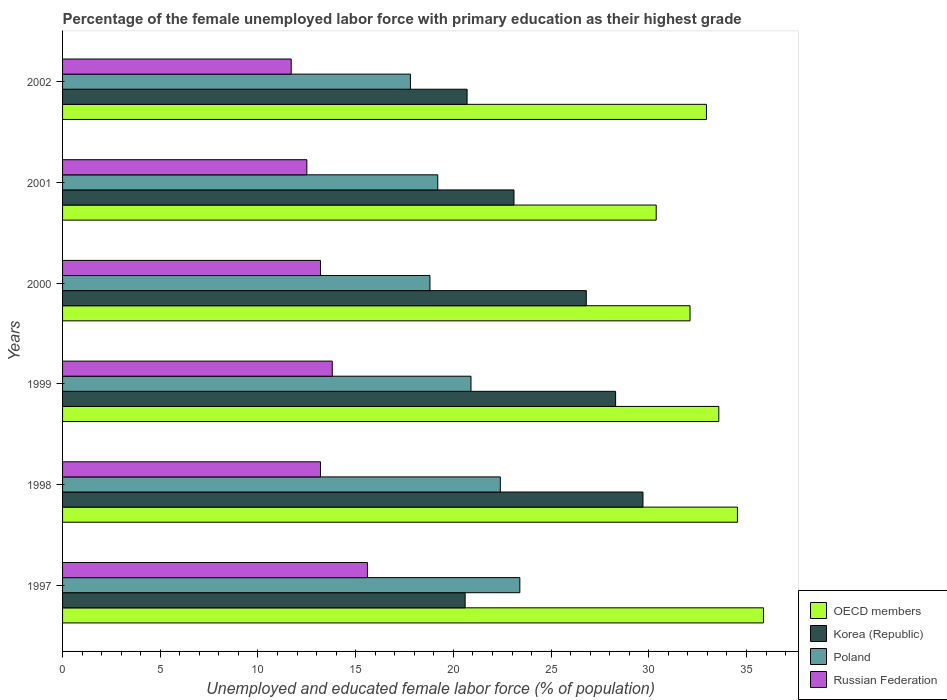How many different coloured bars are there?
Keep it short and to the point. 4. How many groups of bars are there?
Make the answer very short. 6. Are the number of bars per tick equal to the number of legend labels?
Ensure brevity in your answer.  Yes. Are the number of bars on each tick of the Y-axis equal?
Your answer should be very brief. Yes. What is the label of the 2nd group of bars from the top?
Keep it short and to the point. 2001. What is the percentage of the unemployed female labor force with primary education in OECD members in 1998?
Provide a succinct answer. 34.54. Across all years, what is the maximum percentage of the unemployed female labor force with primary education in OECD members?
Make the answer very short. 35.87. Across all years, what is the minimum percentage of the unemployed female labor force with primary education in Korea (Republic)?
Offer a terse response. 20.6. In which year was the percentage of the unemployed female labor force with primary education in OECD members maximum?
Your answer should be compact. 1997. In which year was the percentage of the unemployed female labor force with primary education in Korea (Republic) minimum?
Your answer should be compact. 1997. What is the total percentage of the unemployed female labor force with primary education in Korea (Republic) in the graph?
Keep it short and to the point. 149.2. What is the difference between the percentage of the unemployed female labor force with primary education in Korea (Republic) in 1999 and that in 2002?
Your answer should be compact. 7.6. What is the difference between the percentage of the unemployed female labor force with primary education in Korea (Republic) in 1998 and the percentage of the unemployed female labor force with primary education in OECD members in 2001?
Keep it short and to the point. -0.68. What is the average percentage of the unemployed female labor force with primary education in Russian Federation per year?
Make the answer very short. 13.33. In the year 1997, what is the difference between the percentage of the unemployed female labor force with primary education in Korea (Republic) and percentage of the unemployed female labor force with primary education in Russian Federation?
Provide a succinct answer. 5. In how many years, is the percentage of the unemployed female labor force with primary education in Russian Federation greater than 33 %?
Your answer should be very brief. 0. What is the ratio of the percentage of the unemployed female labor force with primary education in Russian Federation in 1997 to that in 2002?
Your answer should be very brief. 1.33. Is the percentage of the unemployed female labor force with primary education in Russian Federation in 1997 less than that in 2000?
Give a very brief answer. No. What is the difference between the highest and the second highest percentage of the unemployed female labor force with primary education in Russian Federation?
Offer a very short reply. 1.8. What is the difference between the highest and the lowest percentage of the unemployed female labor force with primary education in OECD members?
Provide a succinct answer. 5.49. Is the sum of the percentage of the unemployed female labor force with primary education in OECD members in 1997 and 1998 greater than the maximum percentage of the unemployed female labor force with primary education in Russian Federation across all years?
Offer a very short reply. Yes. Is it the case that in every year, the sum of the percentage of the unemployed female labor force with primary education in Korea (Republic) and percentage of the unemployed female labor force with primary education in Russian Federation is greater than the sum of percentage of the unemployed female labor force with primary education in Poland and percentage of the unemployed female labor force with primary education in OECD members?
Keep it short and to the point. Yes. What does the 2nd bar from the top in 1998 represents?
Ensure brevity in your answer.  Poland. What is the difference between two consecutive major ticks on the X-axis?
Keep it short and to the point. 5. Are the values on the major ticks of X-axis written in scientific E-notation?
Ensure brevity in your answer.  No. Does the graph contain any zero values?
Your answer should be compact. No. Does the graph contain grids?
Ensure brevity in your answer.  No. How many legend labels are there?
Offer a terse response. 4. How are the legend labels stacked?
Give a very brief answer. Vertical. What is the title of the graph?
Make the answer very short. Percentage of the female unemployed labor force with primary education as their highest grade. Does "Haiti" appear as one of the legend labels in the graph?
Your response must be concise. No. What is the label or title of the X-axis?
Provide a short and direct response. Unemployed and educated female labor force (% of population). What is the label or title of the Y-axis?
Give a very brief answer. Years. What is the Unemployed and educated female labor force (% of population) in OECD members in 1997?
Offer a terse response. 35.87. What is the Unemployed and educated female labor force (% of population) of Korea (Republic) in 1997?
Offer a terse response. 20.6. What is the Unemployed and educated female labor force (% of population) in Poland in 1997?
Offer a terse response. 23.4. What is the Unemployed and educated female labor force (% of population) in Russian Federation in 1997?
Give a very brief answer. 15.6. What is the Unemployed and educated female labor force (% of population) of OECD members in 1998?
Your answer should be compact. 34.54. What is the Unemployed and educated female labor force (% of population) of Korea (Republic) in 1998?
Offer a very short reply. 29.7. What is the Unemployed and educated female labor force (% of population) in Poland in 1998?
Provide a short and direct response. 22.4. What is the Unemployed and educated female labor force (% of population) of Russian Federation in 1998?
Your answer should be very brief. 13.2. What is the Unemployed and educated female labor force (% of population) of OECD members in 1999?
Offer a terse response. 33.58. What is the Unemployed and educated female labor force (% of population) of Korea (Republic) in 1999?
Give a very brief answer. 28.3. What is the Unemployed and educated female labor force (% of population) of Poland in 1999?
Offer a terse response. 20.9. What is the Unemployed and educated female labor force (% of population) in Russian Federation in 1999?
Provide a short and direct response. 13.8. What is the Unemployed and educated female labor force (% of population) in OECD members in 2000?
Make the answer very short. 32.11. What is the Unemployed and educated female labor force (% of population) in Korea (Republic) in 2000?
Offer a very short reply. 26.8. What is the Unemployed and educated female labor force (% of population) of Poland in 2000?
Ensure brevity in your answer.  18.8. What is the Unemployed and educated female labor force (% of population) of Russian Federation in 2000?
Provide a short and direct response. 13.2. What is the Unemployed and educated female labor force (% of population) in OECD members in 2001?
Keep it short and to the point. 30.38. What is the Unemployed and educated female labor force (% of population) in Korea (Republic) in 2001?
Ensure brevity in your answer.  23.1. What is the Unemployed and educated female labor force (% of population) in Poland in 2001?
Keep it short and to the point. 19.2. What is the Unemployed and educated female labor force (% of population) in OECD members in 2002?
Your answer should be compact. 32.95. What is the Unemployed and educated female labor force (% of population) in Korea (Republic) in 2002?
Give a very brief answer. 20.7. What is the Unemployed and educated female labor force (% of population) in Poland in 2002?
Your response must be concise. 17.8. What is the Unemployed and educated female labor force (% of population) in Russian Federation in 2002?
Your answer should be very brief. 11.7. Across all years, what is the maximum Unemployed and educated female labor force (% of population) in OECD members?
Keep it short and to the point. 35.87. Across all years, what is the maximum Unemployed and educated female labor force (% of population) of Korea (Republic)?
Offer a very short reply. 29.7. Across all years, what is the maximum Unemployed and educated female labor force (% of population) in Poland?
Your answer should be very brief. 23.4. Across all years, what is the maximum Unemployed and educated female labor force (% of population) of Russian Federation?
Your response must be concise. 15.6. Across all years, what is the minimum Unemployed and educated female labor force (% of population) in OECD members?
Offer a terse response. 30.38. Across all years, what is the minimum Unemployed and educated female labor force (% of population) of Korea (Republic)?
Provide a short and direct response. 20.6. Across all years, what is the minimum Unemployed and educated female labor force (% of population) of Poland?
Your response must be concise. 17.8. Across all years, what is the minimum Unemployed and educated female labor force (% of population) of Russian Federation?
Keep it short and to the point. 11.7. What is the total Unemployed and educated female labor force (% of population) in OECD members in the graph?
Keep it short and to the point. 199.42. What is the total Unemployed and educated female labor force (% of population) in Korea (Republic) in the graph?
Make the answer very short. 149.2. What is the total Unemployed and educated female labor force (% of population) in Poland in the graph?
Your response must be concise. 122.5. What is the total Unemployed and educated female labor force (% of population) of Russian Federation in the graph?
Keep it short and to the point. 80. What is the difference between the Unemployed and educated female labor force (% of population) of OECD members in 1997 and that in 1998?
Make the answer very short. 1.33. What is the difference between the Unemployed and educated female labor force (% of population) in Poland in 1997 and that in 1998?
Provide a succinct answer. 1. What is the difference between the Unemployed and educated female labor force (% of population) of Russian Federation in 1997 and that in 1998?
Ensure brevity in your answer.  2.4. What is the difference between the Unemployed and educated female labor force (% of population) in OECD members in 1997 and that in 1999?
Your response must be concise. 2.29. What is the difference between the Unemployed and educated female labor force (% of population) of Russian Federation in 1997 and that in 1999?
Keep it short and to the point. 1.8. What is the difference between the Unemployed and educated female labor force (% of population) in OECD members in 1997 and that in 2000?
Offer a very short reply. 3.76. What is the difference between the Unemployed and educated female labor force (% of population) in Korea (Republic) in 1997 and that in 2000?
Your answer should be compact. -6.2. What is the difference between the Unemployed and educated female labor force (% of population) of Poland in 1997 and that in 2000?
Your answer should be very brief. 4.6. What is the difference between the Unemployed and educated female labor force (% of population) of OECD members in 1997 and that in 2001?
Offer a very short reply. 5.49. What is the difference between the Unemployed and educated female labor force (% of population) of Russian Federation in 1997 and that in 2001?
Your answer should be compact. 3.1. What is the difference between the Unemployed and educated female labor force (% of population) in OECD members in 1997 and that in 2002?
Offer a very short reply. 2.92. What is the difference between the Unemployed and educated female labor force (% of population) in Poland in 1997 and that in 2002?
Provide a succinct answer. 5.6. What is the difference between the Unemployed and educated female labor force (% of population) of Russian Federation in 1997 and that in 2002?
Your response must be concise. 3.9. What is the difference between the Unemployed and educated female labor force (% of population) in OECD members in 1998 and that in 1999?
Provide a short and direct response. 0.95. What is the difference between the Unemployed and educated female labor force (% of population) in OECD members in 1998 and that in 2000?
Offer a terse response. 2.43. What is the difference between the Unemployed and educated female labor force (% of population) of Poland in 1998 and that in 2000?
Give a very brief answer. 3.6. What is the difference between the Unemployed and educated female labor force (% of population) of OECD members in 1998 and that in 2001?
Your response must be concise. 4.16. What is the difference between the Unemployed and educated female labor force (% of population) in Korea (Republic) in 1998 and that in 2001?
Offer a very short reply. 6.6. What is the difference between the Unemployed and educated female labor force (% of population) in Russian Federation in 1998 and that in 2001?
Offer a very short reply. 0.7. What is the difference between the Unemployed and educated female labor force (% of population) in OECD members in 1998 and that in 2002?
Your response must be concise. 1.59. What is the difference between the Unemployed and educated female labor force (% of population) in Poland in 1998 and that in 2002?
Provide a succinct answer. 4.6. What is the difference between the Unemployed and educated female labor force (% of population) in Russian Federation in 1998 and that in 2002?
Offer a terse response. 1.5. What is the difference between the Unemployed and educated female labor force (% of population) of OECD members in 1999 and that in 2000?
Provide a succinct answer. 1.47. What is the difference between the Unemployed and educated female labor force (% of population) in Korea (Republic) in 1999 and that in 2000?
Provide a succinct answer. 1.5. What is the difference between the Unemployed and educated female labor force (% of population) in OECD members in 1999 and that in 2001?
Ensure brevity in your answer.  3.2. What is the difference between the Unemployed and educated female labor force (% of population) of Poland in 1999 and that in 2001?
Your response must be concise. 1.7. What is the difference between the Unemployed and educated female labor force (% of population) of OECD members in 1999 and that in 2002?
Ensure brevity in your answer.  0.63. What is the difference between the Unemployed and educated female labor force (% of population) in Korea (Republic) in 1999 and that in 2002?
Offer a very short reply. 7.6. What is the difference between the Unemployed and educated female labor force (% of population) of Poland in 1999 and that in 2002?
Make the answer very short. 3.1. What is the difference between the Unemployed and educated female labor force (% of population) in Russian Federation in 1999 and that in 2002?
Make the answer very short. 2.1. What is the difference between the Unemployed and educated female labor force (% of population) of OECD members in 2000 and that in 2001?
Provide a succinct answer. 1.73. What is the difference between the Unemployed and educated female labor force (% of population) in Russian Federation in 2000 and that in 2001?
Keep it short and to the point. 0.7. What is the difference between the Unemployed and educated female labor force (% of population) of OECD members in 2000 and that in 2002?
Offer a terse response. -0.84. What is the difference between the Unemployed and educated female labor force (% of population) in Korea (Republic) in 2000 and that in 2002?
Offer a very short reply. 6.1. What is the difference between the Unemployed and educated female labor force (% of population) of Poland in 2000 and that in 2002?
Provide a succinct answer. 1. What is the difference between the Unemployed and educated female labor force (% of population) of Russian Federation in 2000 and that in 2002?
Your answer should be very brief. 1.5. What is the difference between the Unemployed and educated female labor force (% of population) of OECD members in 2001 and that in 2002?
Make the answer very short. -2.57. What is the difference between the Unemployed and educated female labor force (% of population) of Poland in 2001 and that in 2002?
Ensure brevity in your answer.  1.4. What is the difference between the Unemployed and educated female labor force (% of population) in OECD members in 1997 and the Unemployed and educated female labor force (% of population) in Korea (Republic) in 1998?
Provide a short and direct response. 6.17. What is the difference between the Unemployed and educated female labor force (% of population) of OECD members in 1997 and the Unemployed and educated female labor force (% of population) of Poland in 1998?
Make the answer very short. 13.47. What is the difference between the Unemployed and educated female labor force (% of population) in OECD members in 1997 and the Unemployed and educated female labor force (% of population) in Russian Federation in 1998?
Provide a succinct answer. 22.67. What is the difference between the Unemployed and educated female labor force (% of population) of Korea (Republic) in 1997 and the Unemployed and educated female labor force (% of population) of Poland in 1998?
Make the answer very short. -1.8. What is the difference between the Unemployed and educated female labor force (% of population) of Korea (Republic) in 1997 and the Unemployed and educated female labor force (% of population) of Russian Federation in 1998?
Make the answer very short. 7.4. What is the difference between the Unemployed and educated female labor force (% of population) in Poland in 1997 and the Unemployed and educated female labor force (% of population) in Russian Federation in 1998?
Offer a very short reply. 10.2. What is the difference between the Unemployed and educated female labor force (% of population) of OECD members in 1997 and the Unemployed and educated female labor force (% of population) of Korea (Republic) in 1999?
Provide a short and direct response. 7.57. What is the difference between the Unemployed and educated female labor force (% of population) in OECD members in 1997 and the Unemployed and educated female labor force (% of population) in Poland in 1999?
Your answer should be very brief. 14.97. What is the difference between the Unemployed and educated female labor force (% of population) in OECD members in 1997 and the Unemployed and educated female labor force (% of population) in Russian Federation in 1999?
Your response must be concise. 22.07. What is the difference between the Unemployed and educated female labor force (% of population) of Korea (Republic) in 1997 and the Unemployed and educated female labor force (% of population) of Poland in 1999?
Offer a very short reply. -0.3. What is the difference between the Unemployed and educated female labor force (% of population) of Poland in 1997 and the Unemployed and educated female labor force (% of population) of Russian Federation in 1999?
Offer a very short reply. 9.6. What is the difference between the Unemployed and educated female labor force (% of population) of OECD members in 1997 and the Unemployed and educated female labor force (% of population) of Korea (Republic) in 2000?
Offer a terse response. 9.07. What is the difference between the Unemployed and educated female labor force (% of population) in OECD members in 1997 and the Unemployed and educated female labor force (% of population) in Poland in 2000?
Offer a very short reply. 17.07. What is the difference between the Unemployed and educated female labor force (% of population) of OECD members in 1997 and the Unemployed and educated female labor force (% of population) of Russian Federation in 2000?
Your response must be concise. 22.67. What is the difference between the Unemployed and educated female labor force (% of population) in Korea (Republic) in 1997 and the Unemployed and educated female labor force (% of population) in Poland in 2000?
Make the answer very short. 1.8. What is the difference between the Unemployed and educated female labor force (% of population) in Korea (Republic) in 1997 and the Unemployed and educated female labor force (% of population) in Russian Federation in 2000?
Your response must be concise. 7.4. What is the difference between the Unemployed and educated female labor force (% of population) in OECD members in 1997 and the Unemployed and educated female labor force (% of population) in Korea (Republic) in 2001?
Your answer should be compact. 12.77. What is the difference between the Unemployed and educated female labor force (% of population) of OECD members in 1997 and the Unemployed and educated female labor force (% of population) of Poland in 2001?
Your response must be concise. 16.67. What is the difference between the Unemployed and educated female labor force (% of population) of OECD members in 1997 and the Unemployed and educated female labor force (% of population) of Russian Federation in 2001?
Provide a short and direct response. 23.37. What is the difference between the Unemployed and educated female labor force (% of population) of Korea (Republic) in 1997 and the Unemployed and educated female labor force (% of population) of Poland in 2001?
Give a very brief answer. 1.4. What is the difference between the Unemployed and educated female labor force (% of population) of Poland in 1997 and the Unemployed and educated female labor force (% of population) of Russian Federation in 2001?
Provide a succinct answer. 10.9. What is the difference between the Unemployed and educated female labor force (% of population) of OECD members in 1997 and the Unemployed and educated female labor force (% of population) of Korea (Republic) in 2002?
Make the answer very short. 15.17. What is the difference between the Unemployed and educated female labor force (% of population) in OECD members in 1997 and the Unemployed and educated female labor force (% of population) in Poland in 2002?
Give a very brief answer. 18.07. What is the difference between the Unemployed and educated female labor force (% of population) in OECD members in 1997 and the Unemployed and educated female labor force (% of population) in Russian Federation in 2002?
Offer a very short reply. 24.17. What is the difference between the Unemployed and educated female labor force (% of population) in Korea (Republic) in 1997 and the Unemployed and educated female labor force (% of population) in Poland in 2002?
Give a very brief answer. 2.8. What is the difference between the Unemployed and educated female labor force (% of population) in OECD members in 1998 and the Unemployed and educated female labor force (% of population) in Korea (Republic) in 1999?
Offer a very short reply. 6.24. What is the difference between the Unemployed and educated female labor force (% of population) of OECD members in 1998 and the Unemployed and educated female labor force (% of population) of Poland in 1999?
Your answer should be very brief. 13.64. What is the difference between the Unemployed and educated female labor force (% of population) in OECD members in 1998 and the Unemployed and educated female labor force (% of population) in Russian Federation in 1999?
Offer a very short reply. 20.74. What is the difference between the Unemployed and educated female labor force (% of population) of Korea (Republic) in 1998 and the Unemployed and educated female labor force (% of population) of Poland in 1999?
Your answer should be very brief. 8.8. What is the difference between the Unemployed and educated female labor force (% of population) in Korea (Republic) in 1998 and the Unemployed and educated female labor force (% of population) in Russian Federation in 1999?
Your answer should be compact. 15.9. What is the difference between the Unemployed and educated female labor force (% of population) of OECD members in 1998 and the Unemployed and educated female labor force (% of population) of Korea (Republic) in 2000?
Give a very brief answer. 7.74. What is the difference between the Unemployed and educated female labor force (% of population) in OECD members in 1998 and the Unemployed and educated female labor force (% of population) in Poland in 2000?
Offer a very short reply. 15.74. What is the difference between the Unemployed and educated female labor force (% of population) of OECD members in 1998 and the Unemployed and educated female labor force (% of population) of Russian Federation in 2000?
Keep it short and to the point. 21.34. What is the difference between the Unemployed and educated female labor force (% of population) of Korea (Republic) in 1998 and the Unemployed and educated female labor force (% of population) of Poland in 2000?
Provide a succinct answer. 10.9. What is the difference between the Unemployed and educated female labor force (% of population) in Korea (Republic) in 1998 and the Unemployed and educated female labor force (% of population) in Russian Federation in 2000?
Ensure brevity in your answer.  16.5. What is the difference between the Unemployed and educated female labor force (% of population) in Poland in 1998 and the Unemployed and educated female labor force (% of population) in Russian Federation in 2000?
Your answer should be very brief. 9.2. What is the difference between the Unemployed and educated female labor force (% of population) of OECD members in 1998 and the Unemployed and educated female labor force (% of population) of Korea (Republic) in 2001?
Offer a terse response. 11.44. What is the difference between the Unemployed and educated female labor force (% of population) of OECD members in 1998 and the Unemployed and educated female labor force (% of population) of Poland in 2001?
Your response must be concise. 15.34. What is the difference between the Unemployed and educated female labor force (% of population) in OECD members in 1998 and the Unemployed and educated female labor force (% of population) in Russian Federation in 2001?
Ensure brevity in your answer.  22.04. What is the difference between the Unemployed and educated female labor force (% of population) in Korea (Republic) in 1998 and the Unemployed and educated female labor force (% of population) in Poland in 2001?
Offer a very short reply. 10.5. What is the difference between the Unemployed and educated female labor force (% of population) in OECD members in 1998 and the Unemployed and educated female labor force (% of population) in Korea (Republic) in 2002?
Your answer should be compact. 13.84. What is the difference between the Unemployed and educated female labor force (% of population) in OECD members in 1998 and the Unemployed and educated female labor force (% of population) in Poland in 2002?
Provide a short and direct response. 16.74. What is the difference between the Unemployed and educated female labor force (% of population) of OECD members in 1998 and the Unemployed and educated female labor force (% of population) of Russian Federation in 2002?
Ensure brevity in your answer.  22.84. What is the difference between the Unemployed and educated female labor force (% of population) in Korea (Republic) in 1998 and the Unemployed and educated female labor force (% of population) in Poland in 2002?
Your answer should be compact. 11.9. What is the difference between the Unemployed and educated female labor force (% of population) in Poland in 1998 and the Unemployed and educated female labor force (% of population) in Russian Federation in 2002?
Keep it short and to the point. 10.7. What is the difference between the Unemployed and educated female labor force (% of population) in OECD members in 1999 and the Unemployed and educated female labor force (% of population) in Korea (Republic) in 2000?
Offer a very short reply. 6.78. What is the difference between the Unemployed and educated female labor force (% of population) of OECD members in 1999 and the Unemployed and educated female labor force (% of population) of Poland in 2000?
Offer a terse response. 14.78. What is the difference between the Unemployed and educated female labor force (% of population) in OECD members in 1999 and the Unemployed and educated female labor force (% of population) in Russian Federation in 2000?
Provide a succinct answer. 20.38. What is the difference between the Unemployed and educated female labor force (% of population) in Korea (Republic) in 1999 and the Unemployed and educated female labor force (% of population) in Russian Federation in 2000?
Ensure brevity in your answer.  15.1. What is the difference between the Unemployed and educated female labor force (% of population) of Poland in 1999 and the Unemployed and educated female labor force (% of population) of Russian Federation in 2000?
Your answer should be very brief. 7.7. What is the difference between the Unemployed and educated female labor force (% of population) in OECD members in 1999 and the Unemployed and educated female labor force (% of population) in Korea (Republic) in 2001?
Your answer should be compact. 10.48. What is the difference between the Unemployed and educated female labor force (% of population) of OECD members in 1999 and the Unemployed and educated female labor force (% of population) of Poland in 2001?
Keep it short and to the point. 14.38. What is the difference between the Unemployed and educated female labor force (% of population) in OECD members in 1999 and the Unemployed and educated female labor force (% of population) in Russian Federation in 2001?
Offer a terse response. 21.08. What is the difference between the Unemployed and educated female labor force (% of population) in Korea (Republic) in 1999 and the Unemployed and educated female labor force (% of population) in Russian Federation in 2001?
Make the answer very short. 15.8. What is the difference between the Unemployed and educated female labor force (% of population) of Poland in 1999 and the Unemployed and educated female labor force (% of population) of Russian Federation in 2001?
Ensure brevity in your answer.  8.4. What is the difference between the Unemployed and educated female labor force (% of population) of OECD members in 1999 and the Unemployed and educated female labor force (% of population) of Korea (Republic) in 2002?
Offer a terse response. 12.88. What is the difference between the Unemployed and educated female labor force (% of population) of OECD members in 1999 and the Unemployed and educated female labor force (% of population) of Poland in 2002?
Offer a terse response. 15.78. What is the difference between the Unemployed and educated female labor force (% of population) of OECD members in 1999 and the Unemployed and educated female labor force (% of population) of Russian Federation in 2002?
Provide a succinct answer. 21.88. What is the difference between the Unemployed and educated female labor force (% of population) in Korea (Republic) in 1999 and the Unemployed and educated female labor force (% of population) in Poland in 2002?
Provide a succinct answer. 10.5. What is the difference between the Unemployed and educated female labor force (% of population) in Korea (Republic) in 1999 and the Unemployed and educated female labor force (% of population) in Russian Federation in 2002?
Your answer should be very brief. 16.6. What is the difference between the Unemployed and educated female labor force (% of population) in OECD members in 2000 and the Unemployed and educated female labor force (% of population) in Korea (Republic) in 2001?
Offer a terse response. 9.01. What is the difference between the Unemployed and educated female labor force (% of population) of OECD members in 2000 and the Unemployed and educated female labor force (% of population) of Poland in 2001?
Give a very brief answer. 12.91. What is the difference between the Unemployed and educated female labor force (% of population) of OECD members in 2000 and the Unemployed and educated female labor force (% of population) of Russian Federation in 2001?
Ensure brevity in your answer.  19.61. What is the difference between the Unemployed and educated female labor force (% of population) of Korea (Republic) in 2000 and the Unemployed and educated female labor force (% of population) of Poland in 2001?
Your response must be concise. 7.6. What is the difference between the Unemployed and educated female labor force (% of population) in OECD members in 2000 and the Unemployed and educated female labor force (% of population) in Korea (Republic) in 2002?
Your response must be concise. 11.41. What is the difference between the Unemployed and educated female labor force (% of population) of OECD members in 2000 and the Unemployed and educated female labor force (% of population) of Poland in 2002?
Your answer should be very brief. 14.31. What is the difference between the Unemployed and educated female labor force (% of population) of OECD members in 2000 and the Unemployed and educated female labor force (% of population) of Russian Federation in 2002?
Provide a succinct answer. 20.41. What is the difference between the Unemployed and educated female labor force (% of population) of Korea (Republic) in 2000 and the Unemployed and educated female labor force (% of population) of Russian Federation in 2002?
Your answer should be compact. 15.1. What is the difference between the Unemployed and educated female labor force (% of population) in OECD members in 2001 and the Unemployed and educated female labor force (% of population) in Korea (Republic) in 2002?
Keep it short and to the point. 9.68. What is the difference between the Unemployed and educated female labor force (% of population) in OECD members in 2001 and the Unemployed and educated female labor force (% of population) in Poland in 2002?
Provide a short and direct response. 12.58. What is the difference between the Unemployed and educated female labor force (% of population) in OECD members in 2001 and the Unemployed and educated female labor force (% of population) in Russian Federation in 2002?
Give a very brief answer. 18.68. What is the difference between the Unemployed and educated female labor force (% of population) of Korea (Republic) in 2001 and the Unemployed and educated female labor force (% of population) of Poland in 2002?
Give a very brief answer. 5.3. What is the difference between the Unemployed and educated female labor force (% of population) in Korea (Republic) in 2001 and the Unemployed and educated female labor force (% of population) in Russian Federation in 2002?
Make the answer very short. 11.4. What is the difference between the Unemployed and educated female labor force (% of population) in Poland in 2001 and the Unemployed and educated female labor force (% of population) in Russian Federation in 2002?
Offer a terse response. 7.5. What is the average Unemployed and educated female labor force (% of population) of OECD members per year?
Offer a terse response. 33.24. What is the average Unemployed and educated female labor force (% of population) in Korea (Republic) per year?
Keep it short and to the point. 24.87. What is the average Unemployed and educated female labor force (% of population) of Poland per year?
Your answer should be very brief. 20.42. What is the average Unemployed and educated female labor force (% of population) of Russian Federation per year?
Your answer should be compact. 13.33. In the year 1997, what is the difference between the Unemployed and educated female labor force (% of population) in OECD members and Unemployed and educated female labor force (% of population) in Korea (Republic)?
Your answer should be very brief. 15.27. In the year 1997, what is the difference between the Unemployed and educated female labor force (% of population) of OECD members and Unemployed and educated female labor force (% of population) of Poland?
Your answer should be compact. 12.47. In the year 1997, what is the difference between the Unemployed and educated female labor force (% of population) of OECD members and Unemployed and educated female labor force (% of population) of Russian Federation?
Give a very brief answer. 20.27. In the year 1997, what is the difference between the Unemployed and educated female labor force (% of population) in Korea (Republic) and Unemployed and educated female labor force (% of population) in Poland?
Give a very brief answer. -2.8. In the year 1997, what is the difference between the Unemployed and educated female labor force (% of population) in Korea (Republic) and Unemployed and educated female labor force (% of population) in Russian Federation?
Provide a succinct answer. 5. In the year 1997, what is the difference between the Unemployed and educated female labor force (% of population) in Poland and Unemployed and educated female labor force (% of population) in Russian Federation?
Give a very brief answer. 7.8. In the year 1998, what is the difference between the Unemployed and educated female labor force (% of population) in OECD members and Unemployed and educated female labor force (% of population) in Korea (Republic)?
Offer a terse response. 4.84. In the year 1998, what is the difference between the Unemployed and educated female labor force (% of population) in OECD members and Unemployed and educated female labor force (% of population) in Poland?
Offer a very short reply. 12.14. In the year 1998, what is the difference between the Unemployed and educated female labor force (% of population) in OECD members and Unemployed and educated female labor force (% of population) in Russian Federation?
Provide a succinct answer. 21.34. In the year 1998, what is the difference between the Unemployed and educated female labor force (% of population) of Korea (Republic) and Unemployed and educated female labor force (% of population) of Poland?
Ensure brevity in your answer.  7.3. In the year 1998, what is the difference between the Unemployed and educated female labor force (% of population) of Korea (Republic) and Unemployed and educated female labor force (% of population) of Russian Federation?
Offer a very short reply. 16.5. In the year 1998, what is the difference between the Unemployed and educated female labor force (% of population) in Poland and Unemployed and educated female labor force (% of population) in Russian Federation?
Offer a very short reply. 9.2. In the year 1999, what is the difference between the Unemployed and educated female labor force (% of population) in OECD members and Unemployed and educated female labor force (% of population) in Korea (Republic)?
Offer a very short reply. 5.28. In the year 1999, what is the difference between the Unemployed and educated female labor force (% of population) in OECD members and Unemployed and educated female labor force (% of population) in Poland?
Offer a very short reply. 12.68. In the year 1999, what is the difference between the Unemployed and educated female labor force (% of population) in OECD members and Unemployed and educated female labor force (% of population) in Russian Federation?
Make the answer very short. 19.78. In the year 1999, what is the difference between the Unemployed and educated female labor force (% of population) in Korea (Republic) and Unemployed and educated female labor force (% of population) in Poland?
Your answer should be compact. 7.4. In the year 2000, what is the difference between the Unemployed and educated female labor force (% of population) of OECD members and Unemployed and educated female labor force (% of population) of Korea (Republic)?
Provide a succinct answer. 5.31. In the year 2000, what is the difference between the Unemployed and educated female labor force (% of population) of OECD members and Unemployed and educated female labor force (% of population) of Poland?
Your answer should be very brief. 13.31. In the year 2000, what is the difference between the Unemployed and educated female labor force (% of population) in OECD members and Unemployed and educated female labor force (% of population) in Russian Federation?
Make the answer very short. 18.91. In the year 2001, what is the difference between the Unemployed and educated female labor force (% of population) in OECD members and Unemployed and educated female labor force (% of population) in Korea (Republic)?
Ensure brevity in your answer.  7.28. In the year 2001, what is the difference between the Unemployed and educated female labor force (% of population) in OECD members and Unemployed and educated female labor force (% of population) in Poland?
Offer a terse response. 11.18. In the year 2001, what is the difference between the Unemployed and educated female labor force (% of population) of OECD members and Unemployed and educated female labor force (% of population) of Russian Federation?
Your response must be concise. 17.88. In the year 2001, what is the difference between the Unemployed and educated female labor force (% of population) in Korea (Republic) and Unemployed and educated female labor force (% of population) in Russian Federation?
Your response must be concise. 10.6. In the year 2001, what is the difference between the Unemployed and educated female labor force (% of population) in Poland and Unemployed and educated female labor force (% of population) in Russian Federation?
Offer a terse response. 6.7. In the year 2002, what is the difference between the Unemployed and educated female labor force (% of population) of OECD members and Unemployed and educated female labor force (% of population) of Korea (Republic)?
Keep it short and to the point. 12.25. In the year 2002, what is the difference between the Unemployed and educated female labor force (% of population) of OECD members and Unemployed and educated female labor force (% of population) of Poland?
Make the answer very short. 15.15. In the year 2002, what is the difference between the Unemployed and educated female labor force (% of population) of OECD members and Unemployed and educated female labor force (% of population) of Russian Federation?
Keep it short and to the point. 21.25. In the year 2002, what is the difference between the Unemployed and educated female labor force (% of population) of Korea (Republic) and Unemployed and educated female labor force (% of population) of Poland?
Provide a short and direct response. 2.9. In the year 2002, what is the difference between the Unemployed and educated female labor force (% of population) of Korea (Republic) and Unemployed and educated female labor force (% of population) of Russian Federation?
Your response must be concise. 9. What is the ratio of the Unemployed and educated female labor force (% of population) of OECD members in 1997 to that in 1998?
Ensure brevity in your answer.  1.04. What is the ratio of the Unemployed and educated female labor force (% of population) of Korea (Republic) in 1997 to that in 1998?
Your response must be concise. 0.69. What is the ratio of the Unemployed and educated female labor force (% of population) in Poland in 1997 to that in 1998?
Your answer should be very brief. 1.04. What is the ratio of the Unemployed and educated female labor force (% of population) of Russian Federation in 1997 to that in 1998?
Make the answer very short. 1.18. What is the ratio of the Unemployed and educated female labor force (% of population) of OECD members in 1997 to that in 1999?
Provide a short and direct response. 1.07. What is the ratio of the Unemployed and educated female labor force (% of population) of Korea (Republic) in 1997 to that in 1999?
Ensure brevity in your answer.  0.73. What is the ratio of the Unemployed and educated female labor force (% of population) in Poland in 1997 to that in 1999?
Your answer should be very brief. 1.12. What is the ratio of the Unemployed and educated female labor force (% of population) in Russian Federation in 1997 to that in 1999?
Keep it short and to the point. 1.13. What is the ratio of the Unemployed and educated female labor force (% of population) of OECD members in 1997 to that in 2000?
Provide a short and direct response. 1.12. What is the ratio of the Unemployed and educated female labor force (% of population) of Korea (Republic) in 1997 to that in 2000?
Give a very brief answer. 0.77. What is the ratio of the Unemployed and educated female labor force (% of population) in Poland in 1997 to that in 2000?
Ensure brevity in your answer.  1.24. What is the ratio of the Unemployed and educated female labor force (% of population) in Russian Federation in 1997 to that in 2000?
Keep it short and to the point. 1.18. What is the ratio of the Unemployed and educated female labor force (% of population) in OECD members in 1997 to that in 2001?
Offer a very short reply. 1.18. What is the ratio of the Unemployed and educated female labor force (% of population) in Korea (Republic) in 1997 to that in 2001?
Ensure brevity in your answer.  0.89. What is the ratio of the Unemployed and educated female labor force (% of population) in Poland in 1997 to that in 2001?
Your answer should be very brief. 1.22. What is the ratio of the Unemployed and educated female labor force (% of population) in Russian Federation in 1997 to that in 2001?
Offer a very short reply. 1.25. What is the ratio of the Unemployed and educated female labor force (% of population) of OECD members in 1997 to that in 2002?
Your response must be concise. 1.09. What is the ratio of the Unemployed and educated female labor force (% of population) of Poland in 1997 to that in 2002?
Give a very brief answer. 1.31. What is the ratio of the Unemployed and educated female labor force (% of population) in OECD members in 1998 to that in 1999?
Provide a succinct answer. 1.03. What is the ratio of the Unemployed and educated female labor force (% of population) of Korea (Republic) in 1998 to that in 1999?
Your answer should be very brief. 1.05. What is the ratio of the Unemployed and educated female labor force (% of population) of Poland in 1998 to that in 1999?
Make the answer very short. 1.07. What is the ratio of the Unemployed and educated female labor force (% of population) of Russian Federation in 1998 to that in 1999?
Provide a short and direct response. 0.96. What is the ratio of the Unemployed and educated female labor force (% of population) of OECD members in 1998 to that in 2000?
Your response must be concise. 1.08. What is the ratio of the Unemployed and educated female labor force (% of population) in Korea (Republic) in 1998 to that in 2000?
Offer a terse response. 1.11. What is the ratio of the Unemployed and educated female labor force (% of population) in Poland in 1998 to that in 2000?
Ensure brevity in your answer.  1.19. What is the ratio of the Unemployed and educated female labor force (% of population) in OECD members in 1998 to that in 2001?
Keep it short and to the point. 1.14. What is the ratio of the Unemployed and educated female labor force (% of population) in Poland in 1998 to that in 2001?
Make the answer very short. 1.17. What is the ratio of the Unemployed and educated female labor force (% of population) in Russian Federation in 1998 to that in 2001?
Provide a succinct answer. 1.06. What is the ratio of the Unemployed and educated female labor force (% of population) of OECD members in 1998 to that in 2002?
Ensure brevity in your answer.  1.05. What is the ratio of the Unemployed and educated female labor force (% of population) of Korea (Republic) in 1998 to that in 2002?
Your response must be concise. 1.43. What is the ratio of the Unemployed and educated female labor force (% of population) of Poland in 1998 to that in 2002?
Offer a terse response. 1.26. What is the ratio of the Unemployed and educated female labor force (% of population) of Russian Federation in 1998 to that in 2002?
Provide a succinct answer. 1.13. What is the ratio of the Unemployed and educated female labor force (% of population) in OECD members in 1999 to that in 2000?
Your answer should be very brief. 1.05. What is the ratio of the Unemployed and educated female labor force (% of population) of Korea (Republic) in 1999 to that in 2000?
Your answer should be compact. 1.06. What is the ratio of the Unemployed and educated female labor force (% of population) in Poland in 1999 to that in 2000?
Give a very brief answer. 1.11. What is the ratio of the Unemployed and educated female labor force (% of population) in Russian Federation in 1999 to that in 2000?
Give a very brief answer. 1.05. What is the ratio of the Unemployed and educated female labor force (% of population) of OECD members in 1999 to that in 2001?
Your answer should be compact. 1.11. What is the ratio of the Unemployed and educated female labor force (% of population) of Korea (Republic) in 1999 to that in 2001?
Keep it short and to the point. 1.23. What is the ratio of the Unemployed and educated female labor force (% of population) of Poland in 1999 to that in 2001?
Your response must be concise. 1.09. What is the ratio of the Unemployed and educated female labor force (% of population) in Russian Federation in 1999 to that in 2001?
Give a very brief answer. 1.1. What is the ratio of the Unemployed and educated female labor force (% of population) of OECD members in 1999 to that in 2002?
Make the answer very short. 1.02. What is the ratio of the Unemployed and educated female labor force (% of population) of Korea (Republic) in 1999 to that in 2002?
Your answer should be very brief. 1.37. What is the ratio of the Unemployed and educated female labor force (% of population) in Poland in 1999 to that in 2002?
Keep it short and to the point. 1.17. What is the ratio of the Unemployed and educated female labor force (% of population) in Russian Federation in 1999 to that in 2002?
Offer a terse response. 1.18. What is the ratio of the Unemployed and educated female labor force (% of population) of OECD members in 2000 to that in 2001?
Keep it short and to the point. 1.06. What is the ratio of the Unemployed and educated female labor force (% of population) of Korea (Republic) in 2000 to that in 2001?
Offer a terse response. 1.16. What is the ratio of the Unemployed and educated female labor force (% of population) in Poland in 2000 to that in 2001?
Your answer should be compact. 0.98. What is the ratio of the Unemployed and educated female labor force (% of population) in Russian Federation in 2000 to that in 2001?
Provide a short and direct response. 1.06. What is the ratio of the Unemployed and educated female labor force (% of population) of OECD members in 2000 to that in 2002?
Ensure brevity in your answer.  0.97. What is the ratio of the Unemployed and educated female labor force (% of population) of Korea (Republic) in 2000 to that in 2002?
Offer a very short reply. 1.29. What is the ratio of the Unemployed and educated female labor force (% of population) of Poland in 2000 to that in 2002?
Make the answer very short. 1.06. What is the ratio of the Unemployed and educated female labor force (% of population) of Russian Federation in 2000 to that in 2002?
Give a very brief answer. 1.13. What is the ratio of the Unemployed and educated female labor force (% of population) in OECD members in 2001 to that in 2002?
Keep it short and to the point. 0.92. What is the ratio of the Unemployed and educated female labor force (% of population) of Korea (Republic) in 2001 to that in 2002?
Give a very brief answer. 1.12. What is the ratio of the Unemployed and educated female labor force (% of population) of Poland in 2001 to that in 2002?
Your answer should be very brief. 1.08. What is the ratio of the Unemployed and educated female labor force (% of population) of Russian Federation in 2001 to that in 2002?
Keep it short and to the point. 1.07. What is the difference between the highest and the second highest Unemployed and educated female labor force (% of population) of OECD members?
Your answer should be compact. 1.33. What is the difference between the highest and the second highest Unemployed and educated female labor force (% of population) in Korea (Republic)?
Your answer should be compact. 1.4. What is the difference between the highest and the lowest Unemployed and educated female labor force (% of population) in OECD members?
Give a very brief answer. 5.49. What is the difference between the highest and the lowest Unemployed and educated female labor force (% of population) in Poland?
Give a very brief answer. 5.6. 